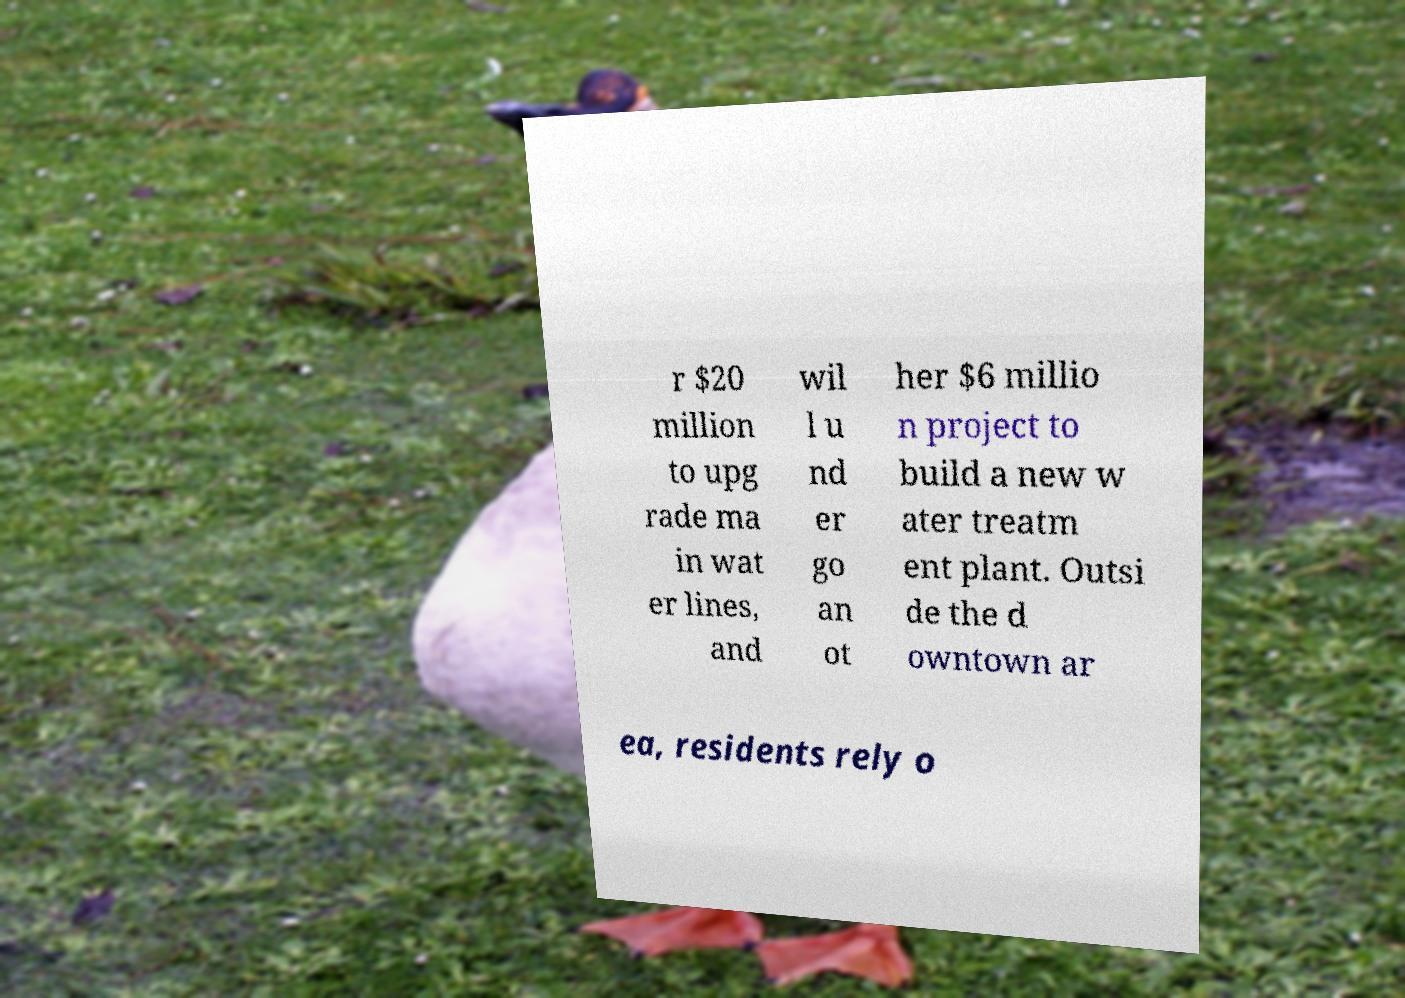Could you assist in decoding the text presented in this image and type it out clearly? r $20 million to upg rade ma in wat er lines, and wil l u nd er go an ot her $6 millio n project to build a new w ater treatm ent plant. Outsi de the d owntown ar ea, residents rely o 